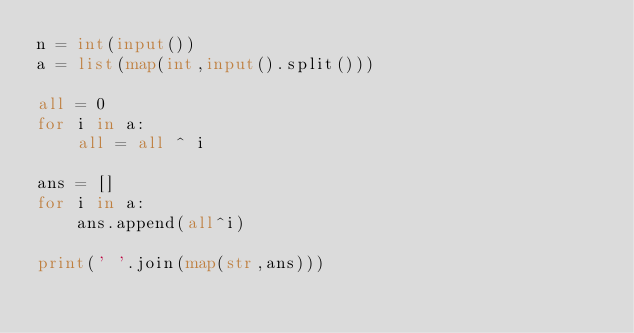Convert code to text. <code><loc_0><loc_0><loc_500><loc_500><_Python_>n = int(input())
a = list(map(int,input().split()))

all = 0
for i in a:
    all = all ^ i

ans = []
for i in a:
    ans.append(all^i)

print(' '.join(map(str,ans)))</code> 